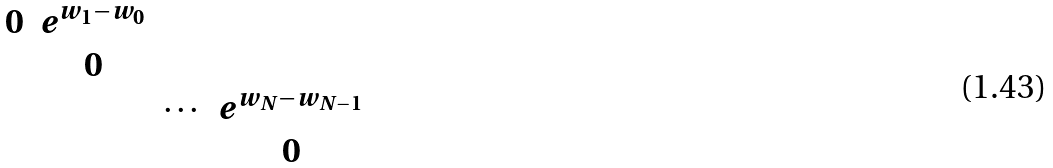<formula> <loc_0><loc_0><loc_500><loc_500>\begin{matrix} 0 & e ^ { w _ { 1 } - w _ { 0 } } & & \\ & 0 & & \\ & & \cdots & e ^ { w _ { N } - w _ { N - 1 } } \\ & & & 0 \\ \end{matrix}</formula> 